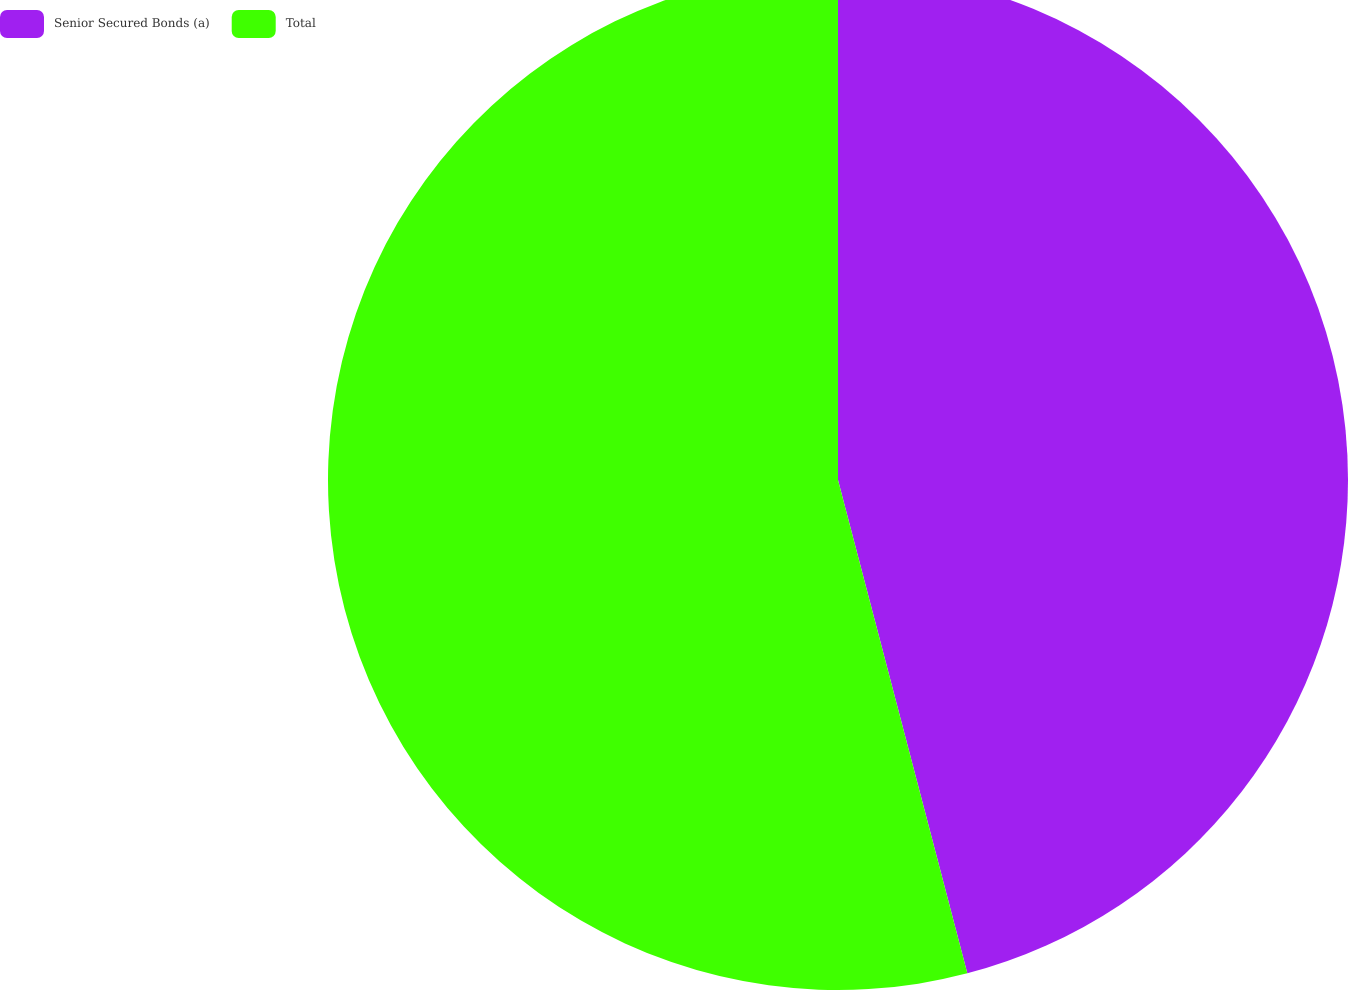<chart> <loc_0><loc_0><loc_500><loc_500><pie_chart><fcel>Senior Secured Bonds (a)<fcel>Total<nl><fcel>45.92%<fcel>54.08%<nl></chart> 